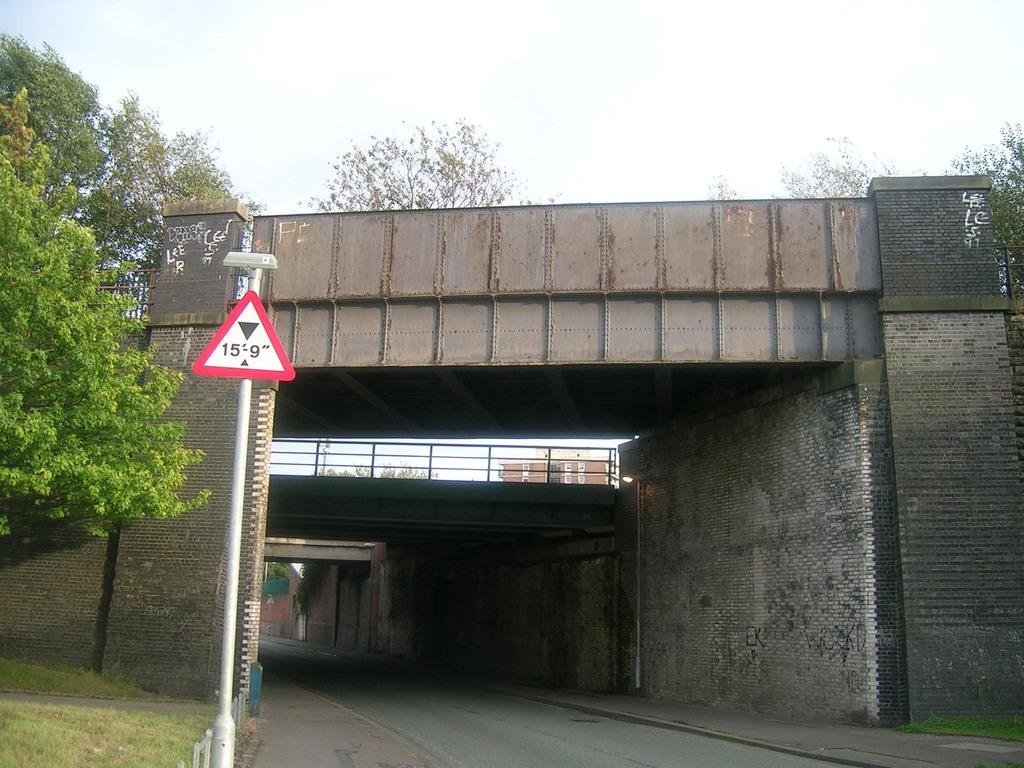What type of structures can be seen in the image? There are bridges, railings, walls, and a building visible in the image. What is attached to the pole in the image? There is a sign board attached to the pole in the image. What type of vegetation is present in the image? Trees and plants are visible in the image. What type of pathways are in the image? Walkways are present in the image. What is visible in the background of the image? The sky and a building are visible in the background of the image. How many rabbits are hopping on the walkways in the image? There are no rabbits present in the image. What type of addition problem can be solved using the numbers on the sign board in the image? There is no sign board with numbers in the image, so it is not possible to solve an addition problem. 